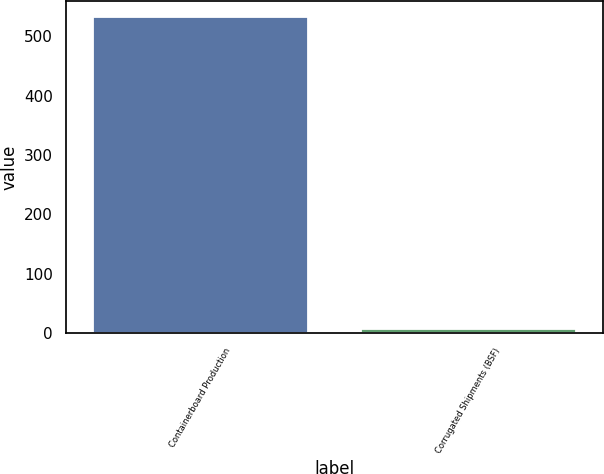Convert chart. <chart><loc_0><loc_0><loc_500><loc_500><bar_chart><fcel>Containerboard Production<fcel>Corrugated Shipments (BSF)<nl><fcel>533<fcel>6.9<nl></chart> 